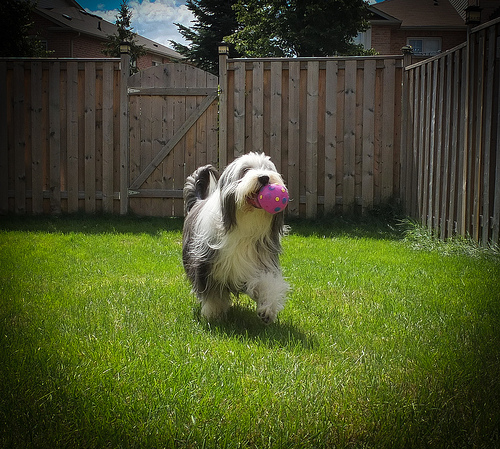<image>
Is there a dog behind the wooden wall? No. The dog is not behind the wooden wall. From this viewpoint, the dog appears to be positioned elsewhere in the scene. Is the ball in the dog? Yes. The ball is contained within or inside the dog, showing a containment relationship. Is there a ball above the dog? No. The ball is not positioned above the dog. The vertical arrangement shows a different relationship. 